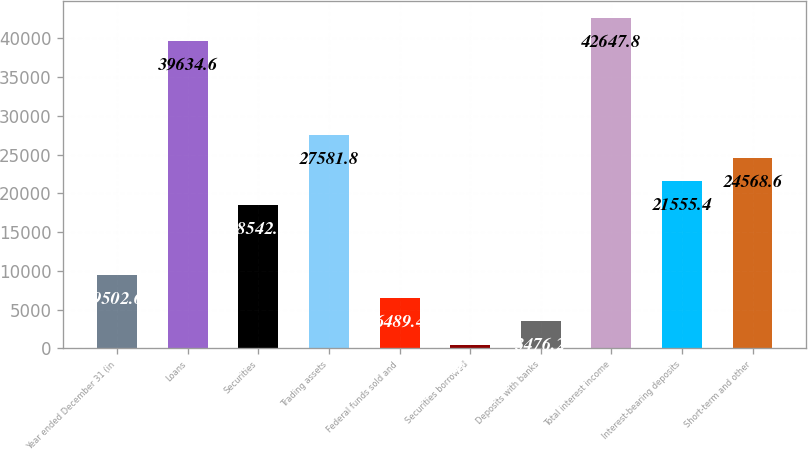<chart> <loc_0><loc_0><loc_500><loc_500><bar_chart><fcel>Year ended December 31 (in<fcel>Loans<fcel>Securities<fcel>Trading assets<fcel>Federal funds sold and<fcel>Securities borrowed<fcel>Deposits with banks<fcel>Total interest income<fcel>Interest-bearing deposits<fcel>Short-term and other<nl><fcel>9502.6<fcel>39634.6<fcel>18542.2<fcel>27581.8<fcel>6489.4<fcel>463<fcel>3476.2<fcel>42647.8<fcel>21555.4<fcel>24568.6<nl></chart> 